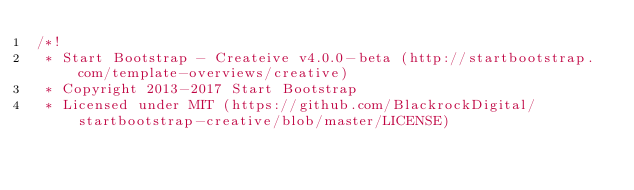Convert code to text. <code><loc_0><loc_0><loc_500><loc_500><_CSS_>/*!
 * Start Bootstrap - Createive v4.0.0-beta (http://startbootstrap.com/template-overviews/creative)
 * Copyright 2013-2017 Start Bootstrap
 * Licensed under MIT (https://github.com/BlackrockDigital/startbootstrap-creative/blob/master/LICENSE)</code> 